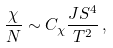Convert formula to latex. <formula><loc_0><loc_0><loc_500><loc_500>\frac { \chi } { N } \sim C _ { \chi } \frac { J S ^ { 4 } } { T ^ { 2 } } \, ,</formula> 